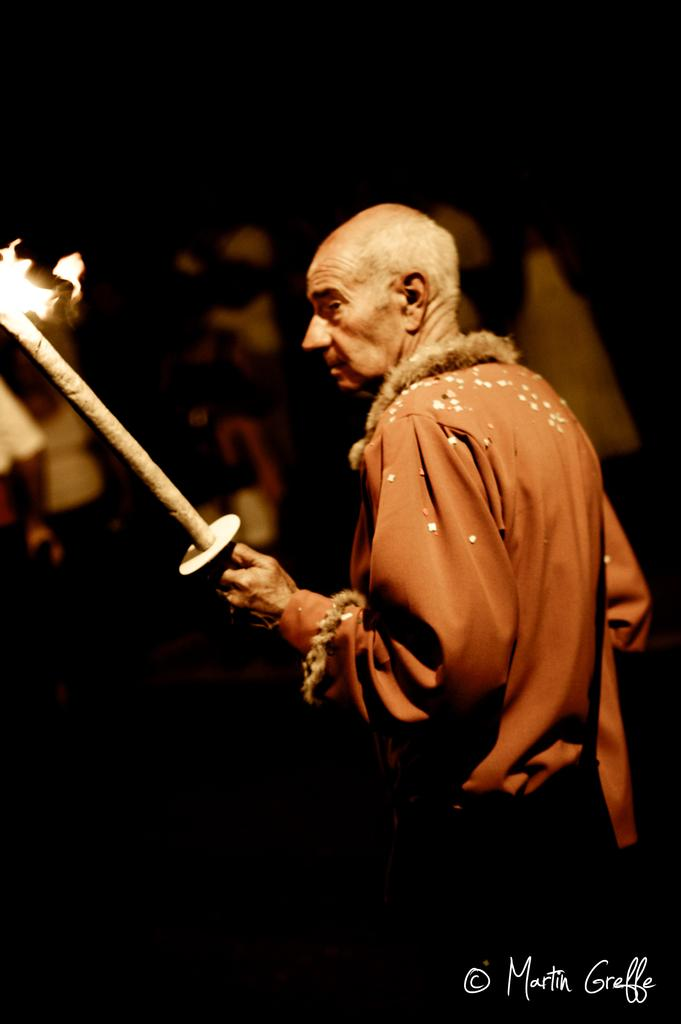What is the main subject of the image? There is a person in the image. What is the person wearing? The person is wearing clothes. What is the person holding in the image? The person is holding a firestick. Is there any text present in the image? Yes, there is text in the bottom right corner of the image. Can you see the person's brain in the image? No, the person's brain is not visible in the image. Is the person jumping in the image? There is no indication that the person is jumping in the image. 